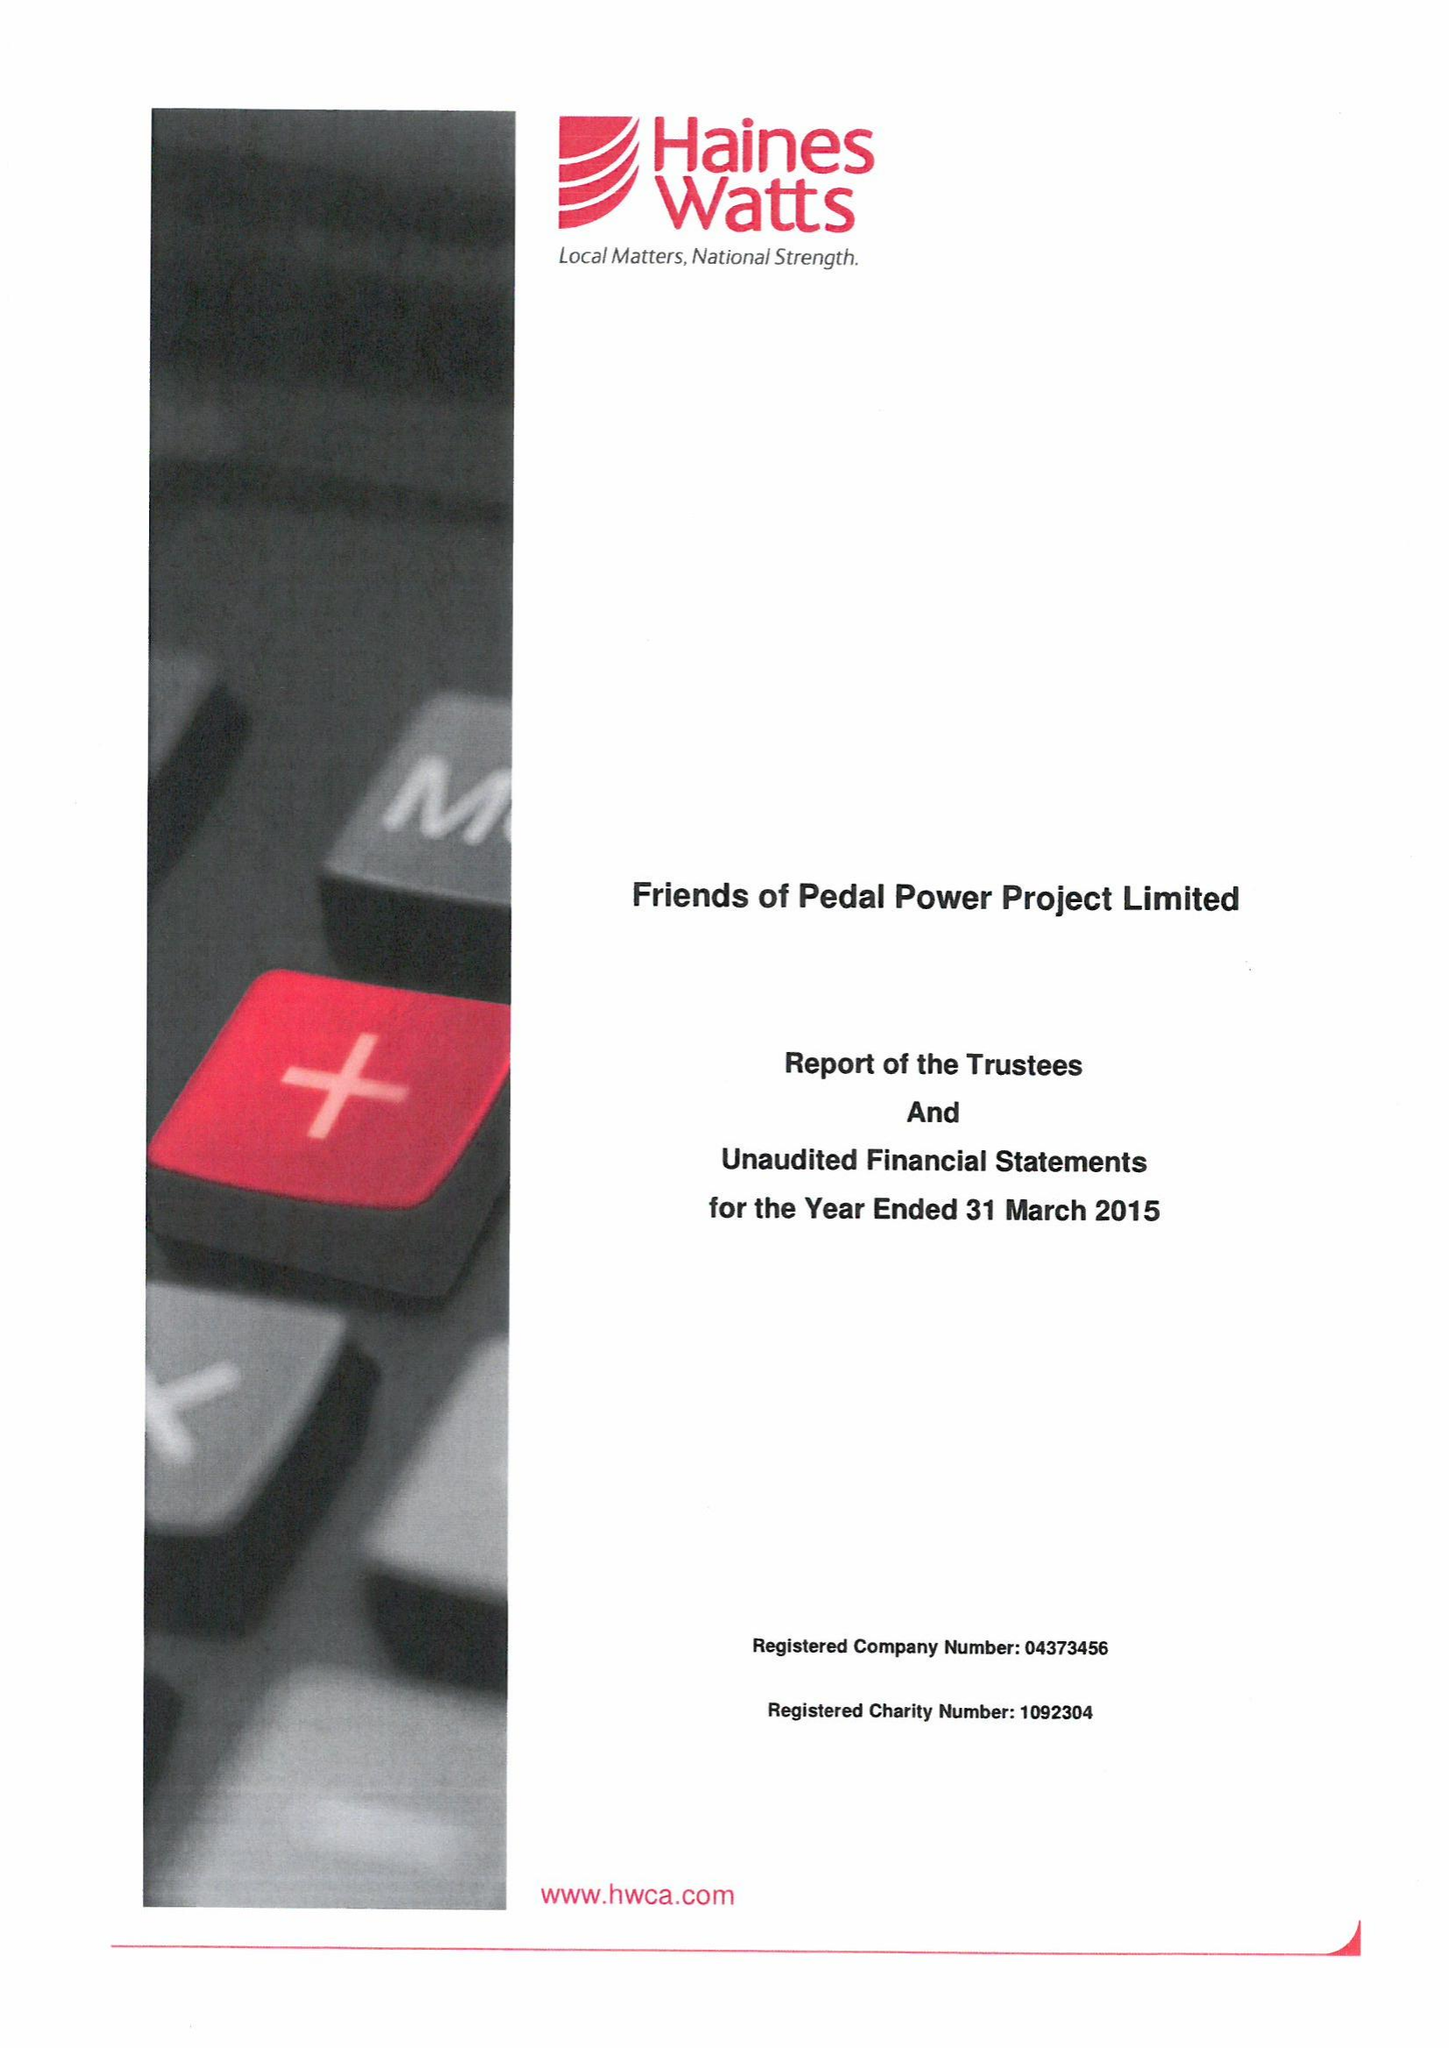What is the value for the income_annually_in_british_pounds?
Answer the question using a single word or phrase. 379881.00 